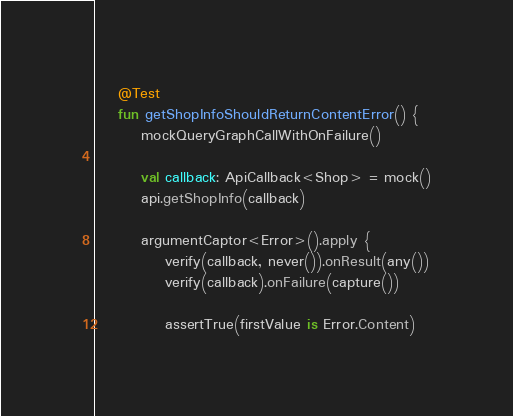Convert code to text. <code><loc_0><loc_0><loc_500><loc_500><_Kotlin_>    @Test
    fun getShopInfoShouldReturnContentError() {
        mockQueryGraphCallWithOnFailure()

        val callback: ApiCallback<Shop> = mock()
        api.getShopInfo(callback)

        argumentCaptor<Error>().apply {
            verify(callback, never()).onResult(any())
            verify(callback).onFailure(capture())

            assertTrue(firstValue is Error.Content)</code> 